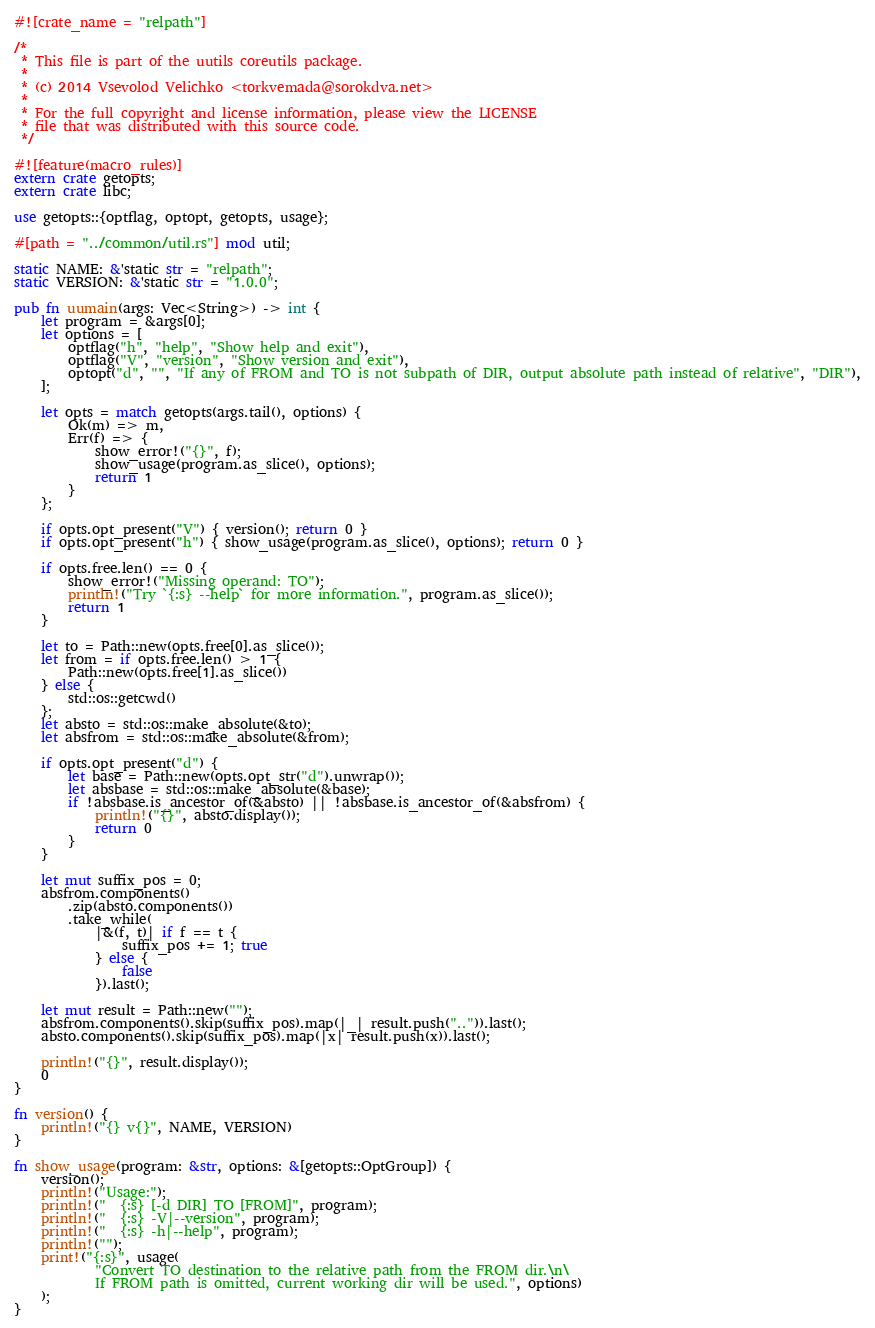<code> <loc_0><loc_0><loc_500><loc_500><_Rust_>#![crate_name = "relpath"]

/*
 * This file is part of the uutils coreutils package.
 *
 * (c) 2014 Vsevolod Velichko <torkvemada@sorokdva.net>
 *
 * For the full copyright and license information, please view the LICENSE
 * file that was distributed with this source code.
 */

#![feature(macro_rules)]
extern crate getopts;
extern crate libc;

use getopts::{optflag, optopt, getopts, usage};

#[path = "../common/util.rs"] mod util;

static NAME: &'static str = "relpath";
static VERSION: &'static str = "1.0.0";

pub fn uumain(args: Vec<String>) -> int {
    let program = &args[0];
    let options = [
        optflag("h", "help", "Show help and exit"),
        optflag("V", "version", "Show version and exit"),
        optopt("d", "", "If any of FROM and TO is not subpath of DIR, output absolute path instead of relative", "DIR"),
    ];

    let opts = match getopts(args.tail(), options) {
        Ok(m) => m,
        Err(f) => {
            show_error!("{}", f);
            show_usage(program.as_slice(), options);
            return 1
        }
    };

    if opts.opt_present("V") { version(); return 0 }
    if opts.opt_present("h") { show_usage(program.as_slice(), options); return 0 }

    if opts.free.len() == 0 {
        show_error!("Missing operand: TO");
        println!("Try `{:s} --help` for more information.", program.as_slice());
        return 1
    }

    let to = Path::new(opts.free[0].as_slice());
    let from = if opts.free.len() > 1 {
        Path::new(opts.free[1].as_slice())
    } else {
        std::os::getcwd()
    };
    let absto = std::os::make_absolute(&to);
    let absfrom = std::os::make_absolute(&from);

    if opts.opt_present("d") {
        let base = Path::new(opts.opt_str("d").unwrap());
        let absbase = std::os::make_absolute(&base);
        if !absbase.is_ancestor_of(&absto) || !absbase.is_ancestor_of(&absfrom) {
            println!("{}", absto.display());
            return 0
        }
    }

    let mut suffix_pos = 0;
    absfrom.components()
        .zip(absto.components())
        .take_while(
            |&(f, t)| if f == t {
                suffix_pos += 1; true
            } else {
                false
            }).last();

    let mut result = Path::new("");
    absfrom.components().skip(suffix_pos).map(|_| result.push("..")).last();
    absto.components().skip(suffix_pos).map(|x| result.push(x)).last();

    println!("{}", result.display());
    0
}

fn version() {
    println!("{} v{}", NAME, VERSION)
}

fn show_usage(program: &str, options: &[getopts::OptGroup]) {
    version();
    println!("Usage:");
    println!("  {:s} [-d DIR] TO [FROM]", program);
    println!("  {:s} -V|--version", program);
    println!("  {:s} -h|--help", program);
    println!("");
    print!("{:s}", usage(
            "Convert TO destination to the relative path from the FROM dir.\n\
            If FROM path is omitted, current working dir will be used.", options)
    );
}
</code> 